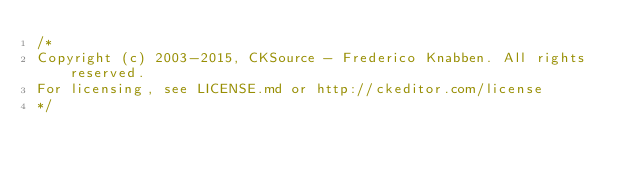Convert code to text. <code><loc_0><loc_0><loc_500><loc_500><_CSS_>/*
Copyright (c) 2003-2015, CKSource - Frederico Knabben. All rights reserved.
For licensing, see LICENSE.md or http://ckeditor.com/license
*/</code> 